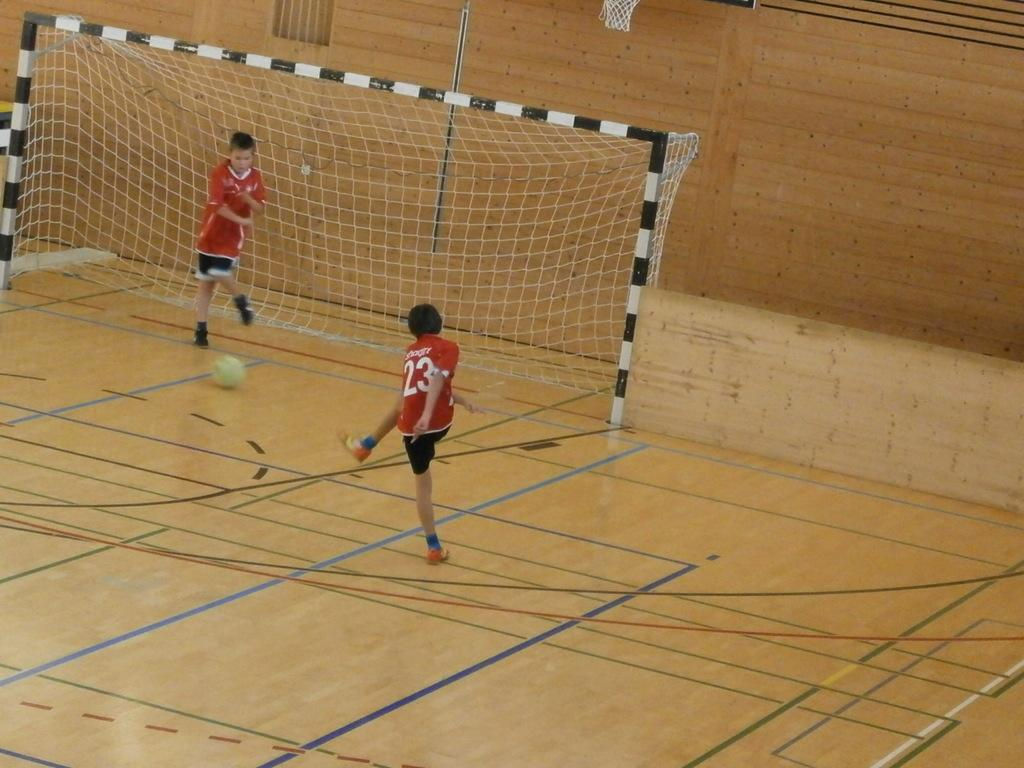Provide a one-sentence caption for the provided image. A player with the number 23 on his jersey is standing near a net. 